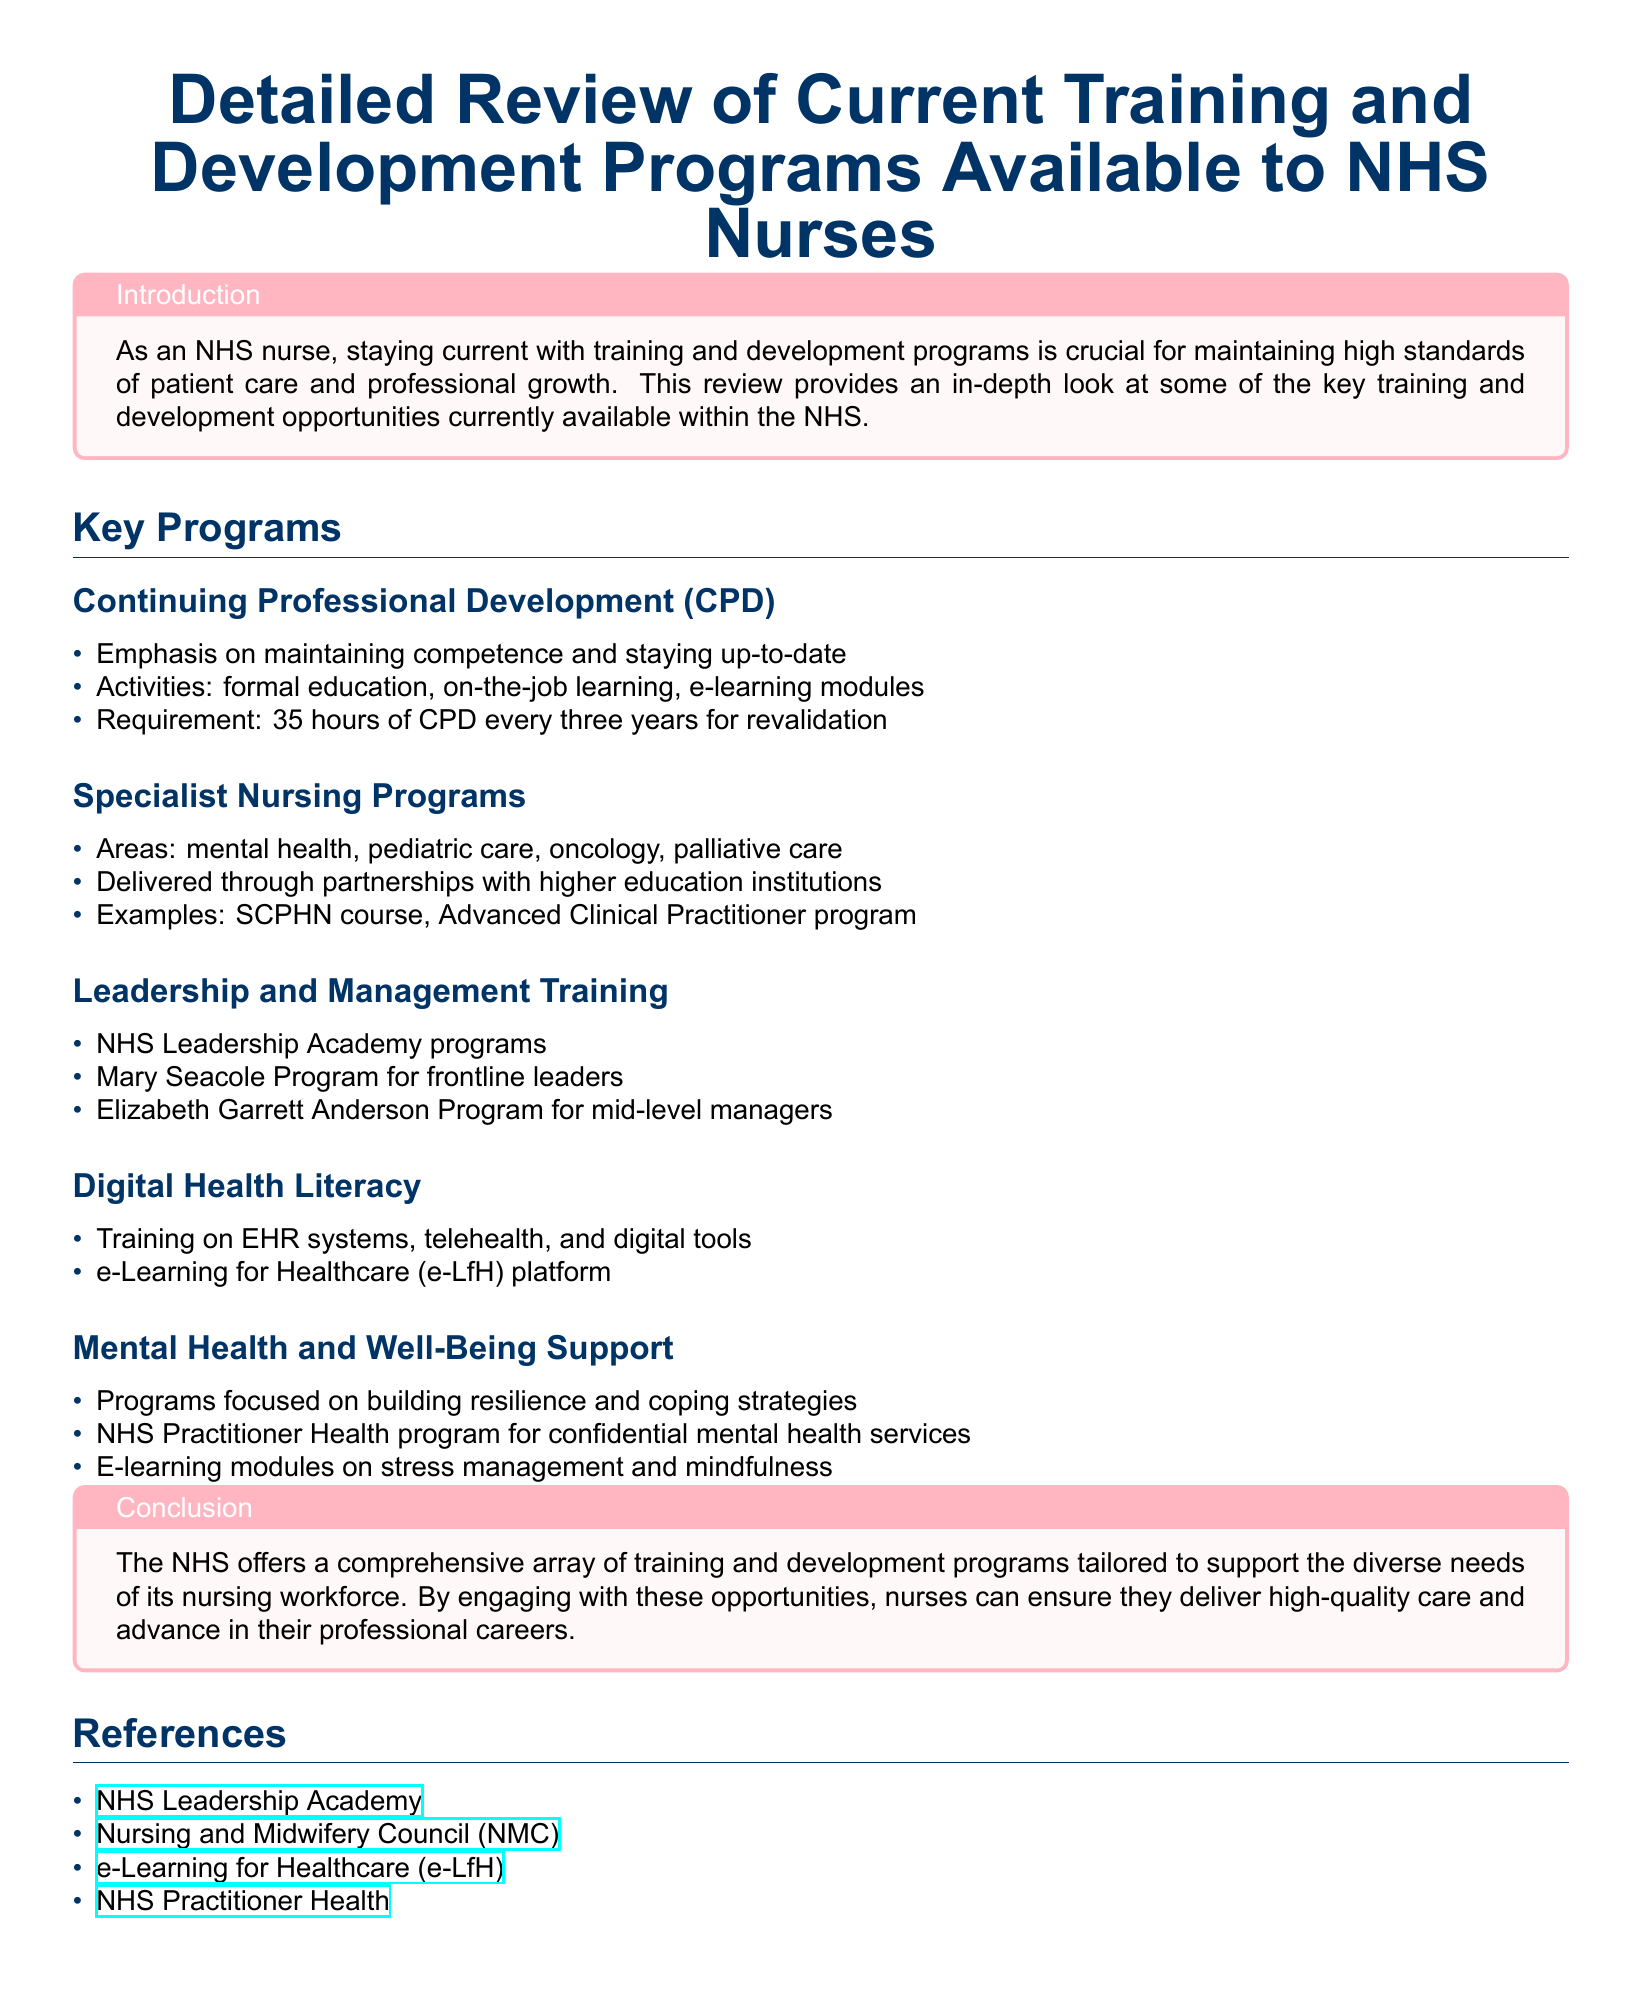What is the required CPD hours for NHS nurses every three years? The document states that NHS nurses must complete 35 hours of CPD every three years for revalidation.
Answer: 35 hours What program is aimed at frontline leaders in the NHS? The document mentions the Mary Seacole Program specifically designed for frontline leaders.
Answer: Mary Seacole Program Which platform provides e-learning resources for NHS nurses? The e-Learning for Healthcare (e-LfH) platform is highlighted in the document as a source for e-learning resources.
Answer: e-Learning for Healthcare (e-LfH) What area of training focuses on building resilience? The document states that programs focused on mental health and well-being support aim to build resilience.
Answer: Mental Health and Well-Being Support What is the focus of the Specialist Nursing Programs? According to the document, the Specialist Nursing Programs cover areas like mental health, pediatric care, oncology, and palliative care.
Answer: Mental health, pediatric care, oncology, palliative care What is the purpose of the NHS Practitioner Health program? The document states that the NHS Practitioner Health program offers confidential mental health services for NHS staff.
Answer: Confidential mental health services 